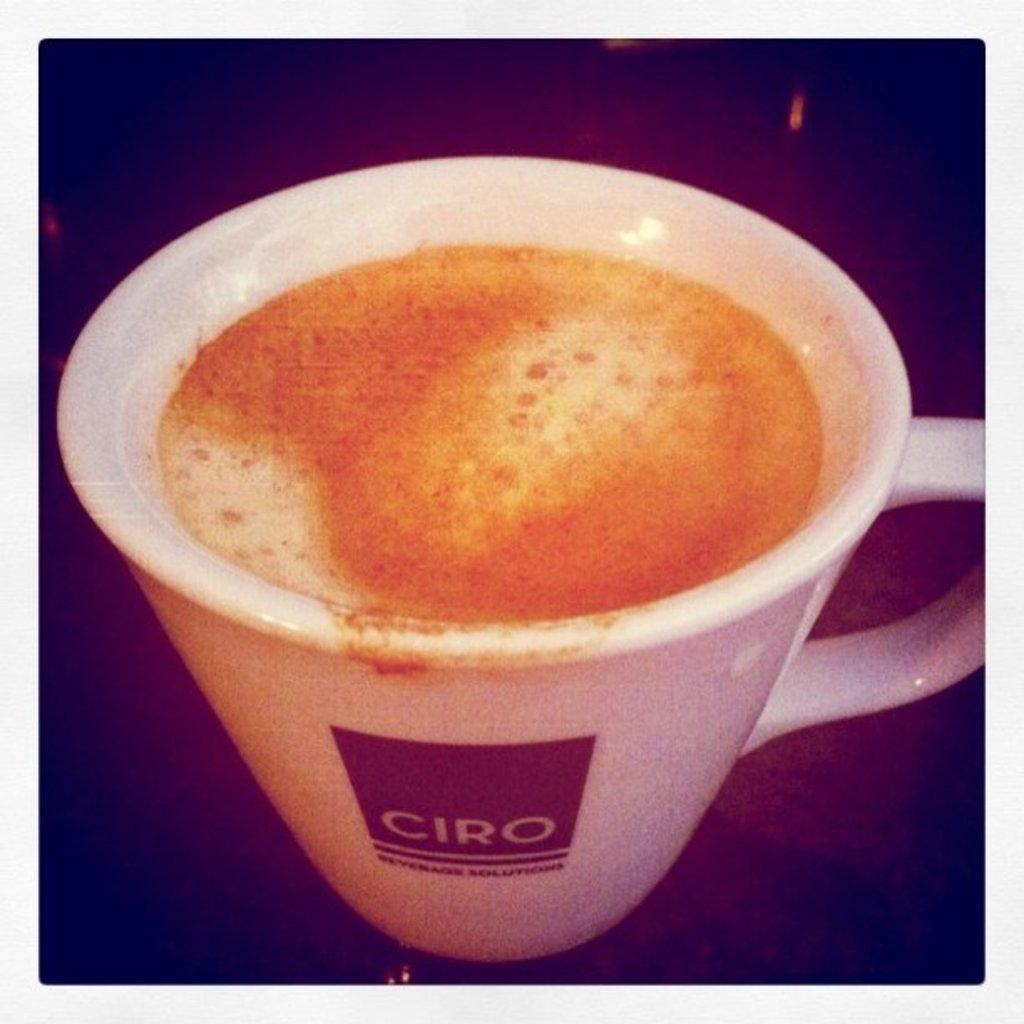What is in the cup that is visible in the image? There is a cup of coffee in the image. Where is the cup of coffee located? The cup of coffee is on a table. Can you describe any specific details about the image? There is darkness in the bottom left corner of the image. Are there any ants crawling on the powder on the sofa in the image? There is no sofa, powder, or ants present in the image. 